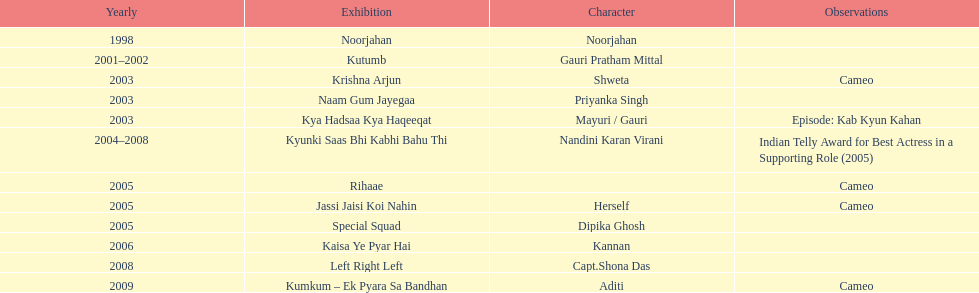How many total television shows has gauri starred in? 12. 